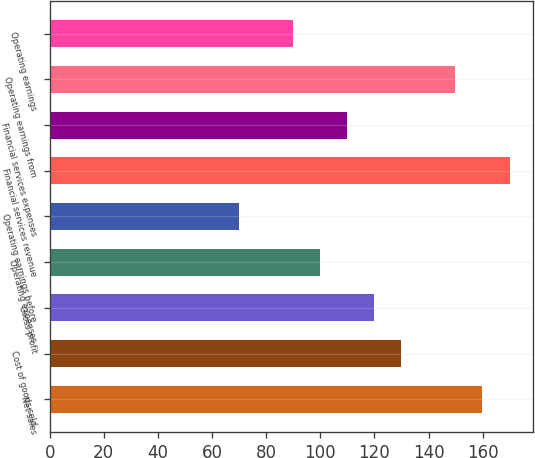<chart> <loc_0><loc_0><loc_500><loc_500><bar_chart><fcel>Net sales<fcel>Cost of goods sold<fcel>Gross profit<fcel>Operating expenses<fcel>Operating earnings before<fcel>Financial services revenue<fcel>Financial services expenses<fcel>Operating earnings from<fcel>Operating earnings<nl><fcel>159.94<fcel>129.97<fcel>119.98<fcel>100<fcel>70.03<fcel>169.93<fcel>109.99<fcel>149.95<fcel>90.01<nl></chart> 